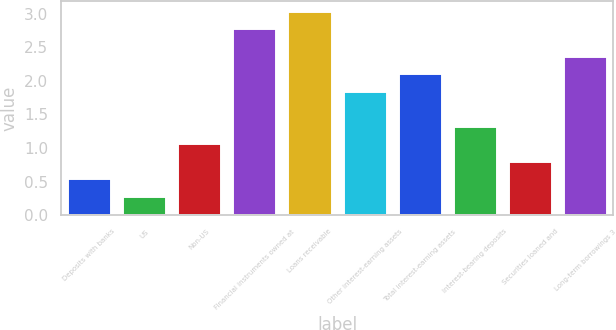<chart> <loc_0><loc_0><loc_500><loc_500><bar_chart><fcel>Deposits with banks<fcel>US<fcel>Non-US<fcel>Financial instruments owned at<fcel>Loans receivable<fcel>Other interest-earning assets<fcel>Total interest-earning assets<fcel>Interest-bearing deposits<fcel>Securities loaned and<fcel>Long-term borrowings 3<nl><fcel>0.55<fcel>0.29<fcel>1.07<fcel>2.78<fcel>3.04<fcel>1.85<fcel>2.11<fcel>1.33<fcel>0.81<fcel>2.37<nl></chart> 